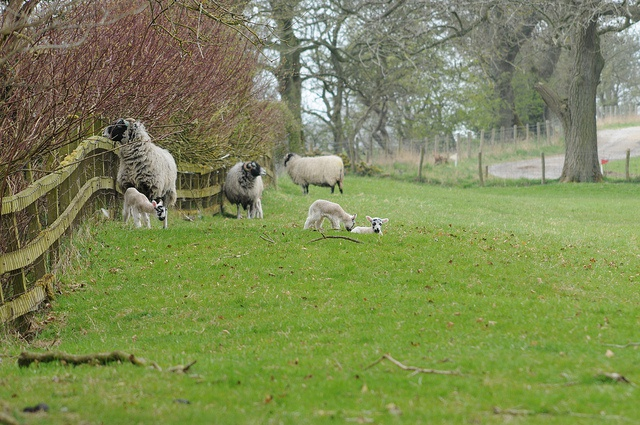Describe the objects in this image and their specific colors. I can see sheep in gray, darkgray, and black tones, sheep in gray, darkgray, and lightgray tones, sheep in gray, black, and darkgray tones, sheep in gray, darkgray, and lightgray tones, and sheep in gray, darkgray, and lightgray tones in this image. 